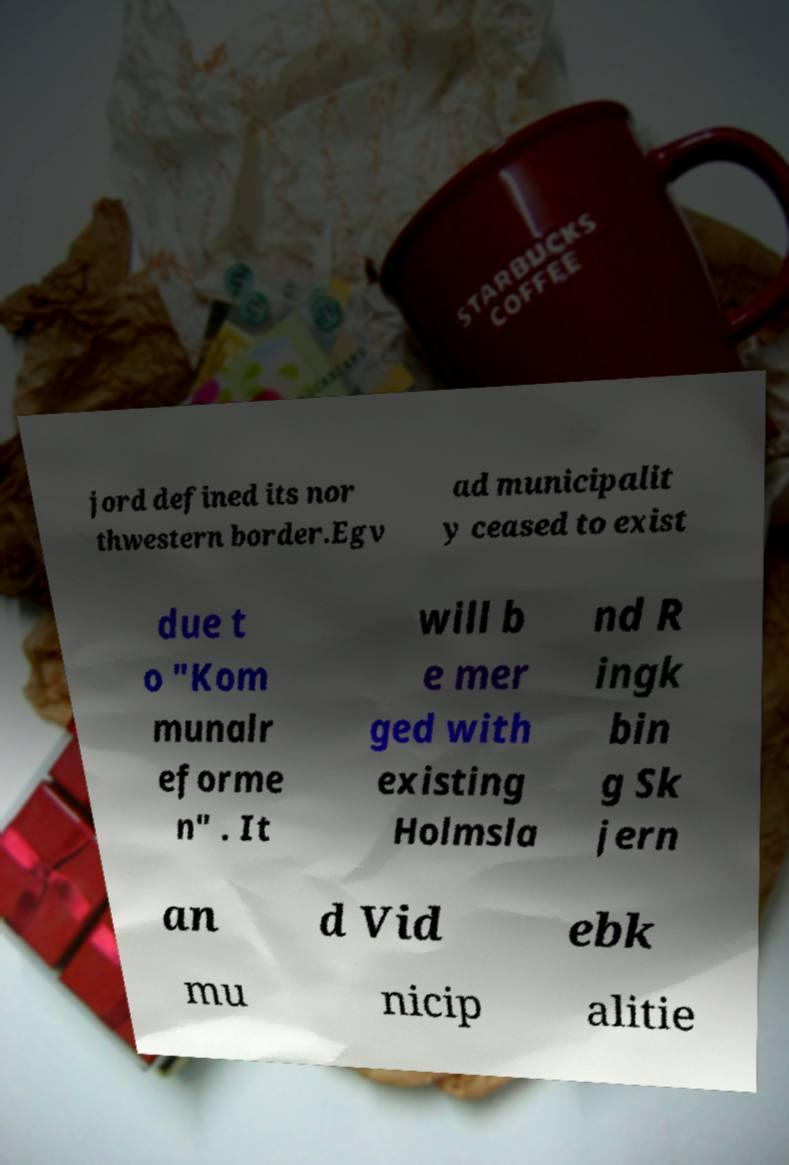Can you accurately transcribe the text from the provided image for me? jord defined its nor thwestern border.Egv ad municipalit y ceased to exist due t o "Kom munalr eforme n" . It will b e mer ged with existing Holmsla nd R ingk bin g Sk jern an d Vid ebk mu nicip alitie 